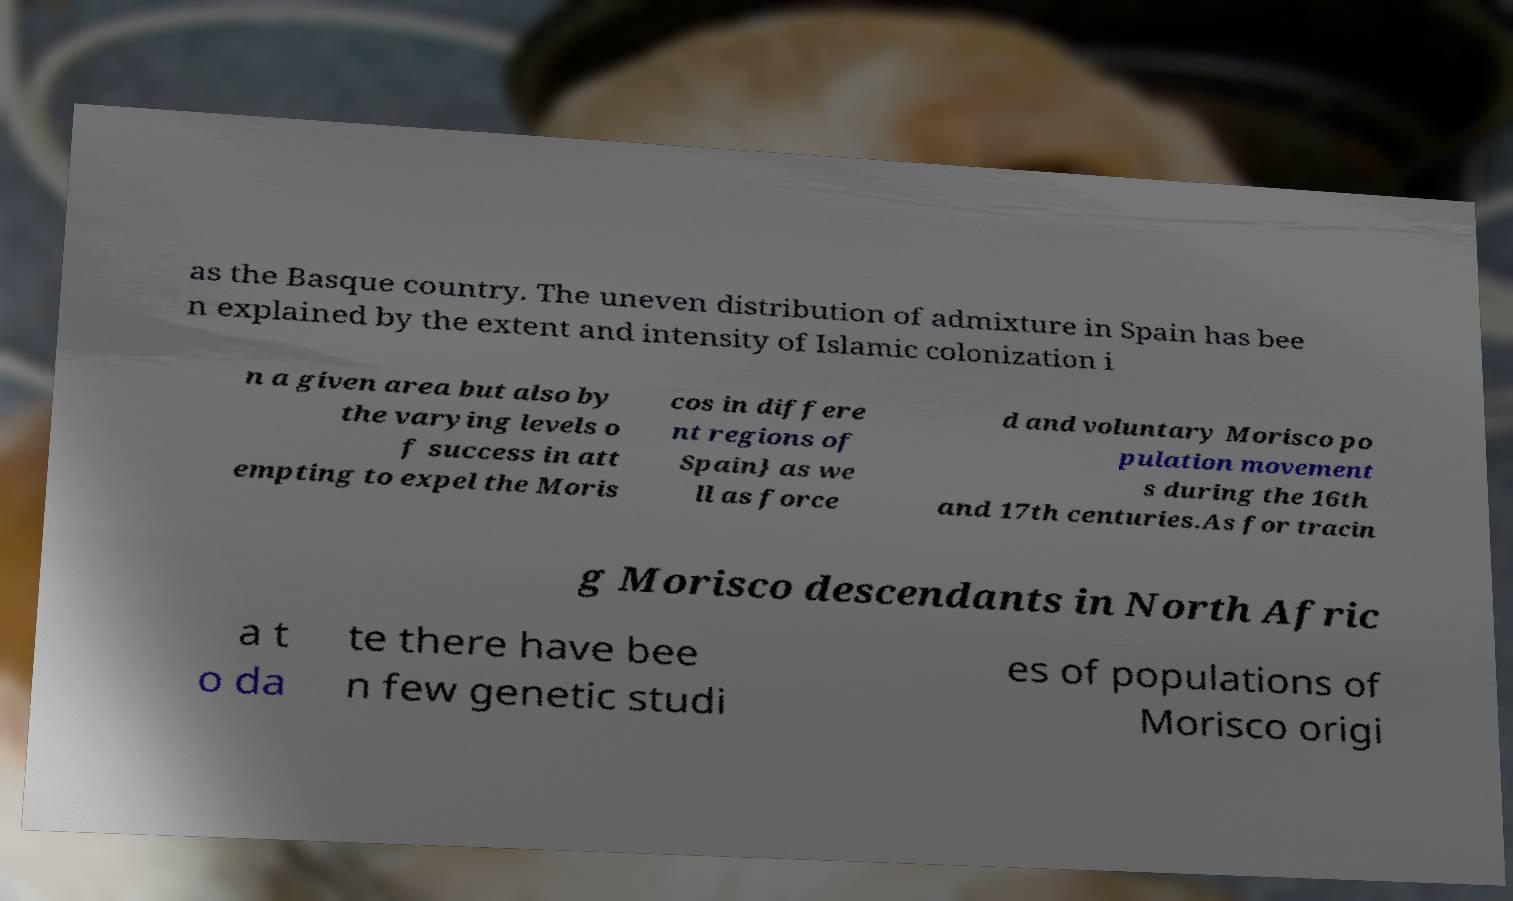There's text embedded in this image that I need extracted. Can you transcribe it verbatim? as the Basque country. The uneven distribution of admixture in Spain has bee n explained by the extent and intensity of Islamic colonization i n a given area but also by the varying levels o f success in att empting to expel the Moris cos in differe nt regions of Spain} as we ll as force d and voluntary Morisco po pulation movement s during the 16th and 17th centuries.As for tracin g Morisco descendants in North Afric a t o da te there have bee n few genetic studi es of populations of Morisco origi 